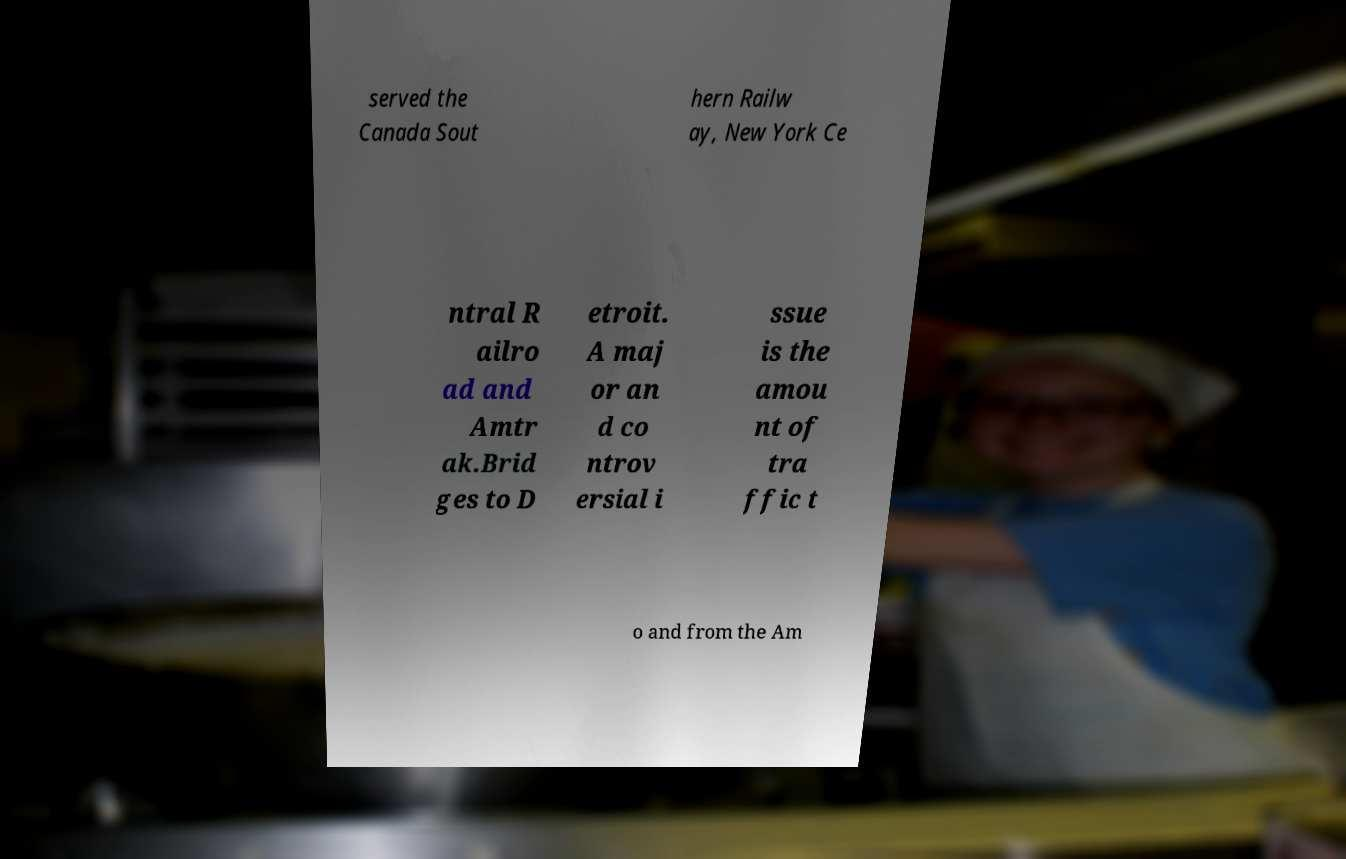Can you accurately transcribe the text from the provided image for me? served the Canada Sout hern Railw ay, New York Ce ntral R ailro ad and Amtr ak.Brid ges to D etroit. A maj or an d co ntrov ersial i ssue is the amou nt of tra ffic t o and from the Am 